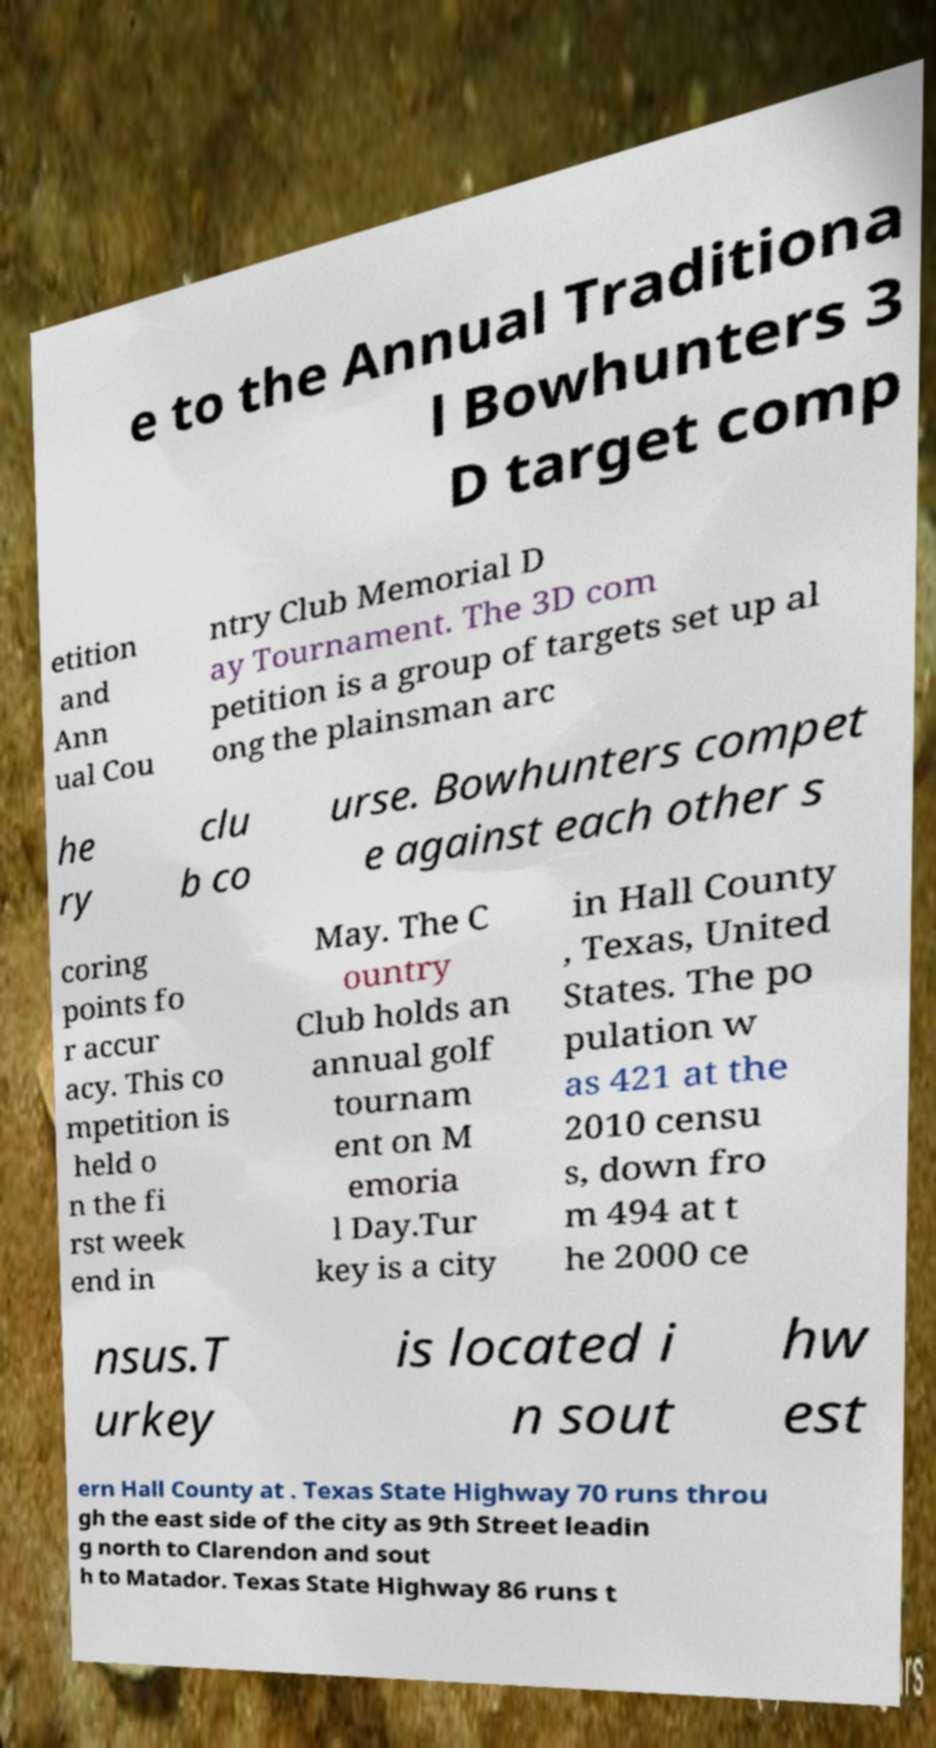Can you accurately transcribe the text from the provided image for me? e to the Annual Traditiona l Bowhunters 3 D target comp etition and Ann ual Cou ntry Club Memorial D ay Tournament. The 3D com petition is a group of targets set up al ong the plainsman arc he ry clu b co urse. Bowhunters compet e against each other s coring points fo r accur acy. This co mpetition is held o n the fi rst week end in May. The C ountry Club holds an annual golf tournam ent on M emoria l Day.Tur key is a city in Hall County , Texas, United States. The po pulation w as 421 at the 2010 censu s, down fro m 494 at t he 2000 ce nsus.T urkey is located i n sout hw est ern Hall County at . Texas State Highway 70 runs throu gh the east side of the city as 9th Street leadin g north to Clarendon and sout h to Matador. Texas State Highway 86 runs t 